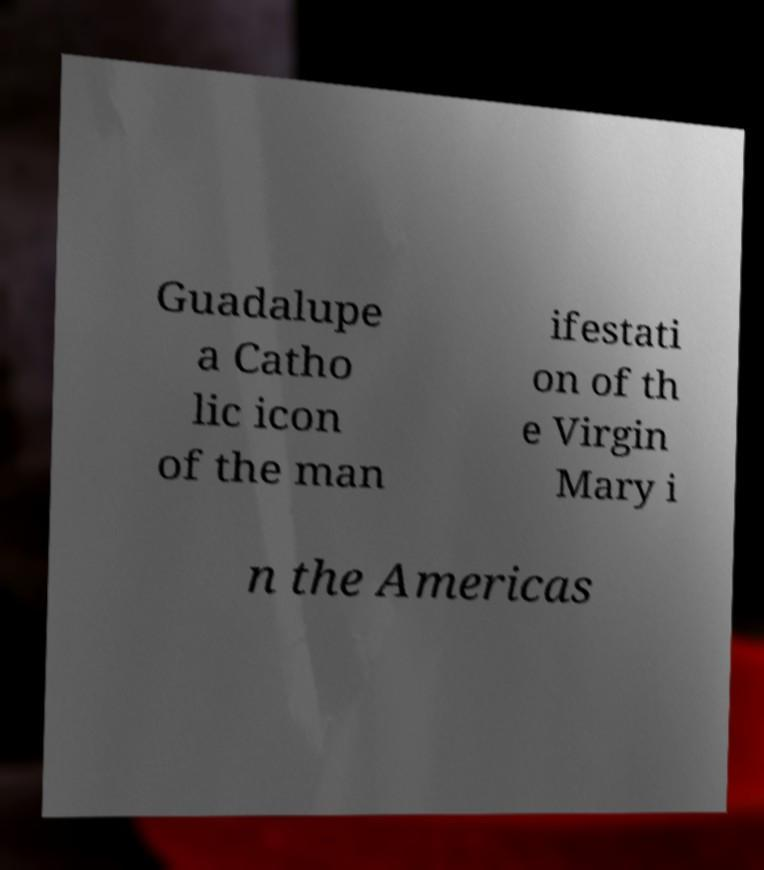Could you assist in decoding the text presented in this image and type it out clearly? Guadalupe a Catho lic icon of the man ifestati on of th e Virgin Mary i n the Americas 